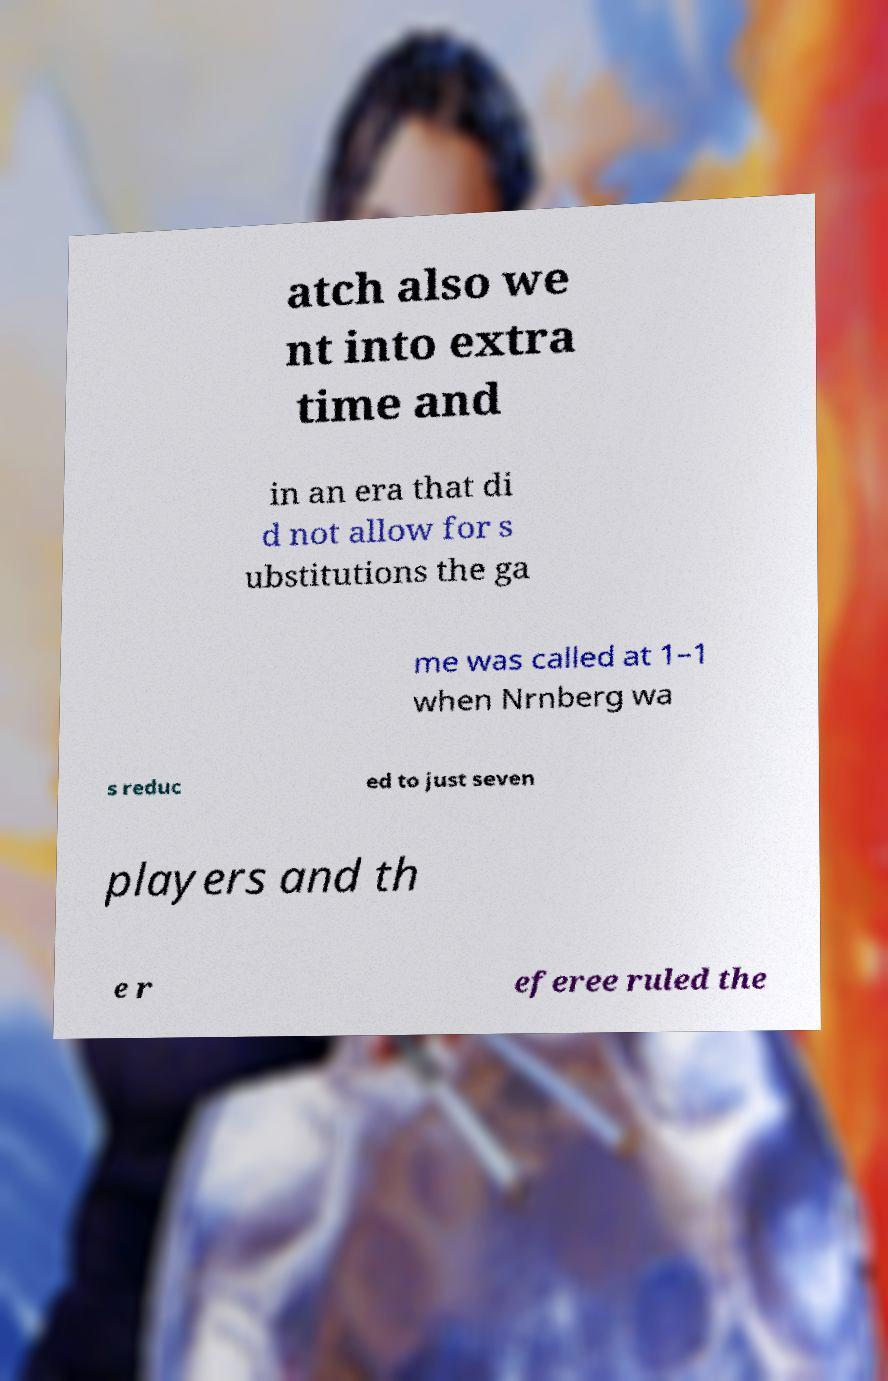For documentation purposes, I need the text within this image transcribed. Could you provide that? atch also we nt into extra time and in an era that di d not allow for s ubstitutions the ga me was called at 1–1 when Nrnberg wa s reduc ed to just seven players and th e r eferee ruled the 